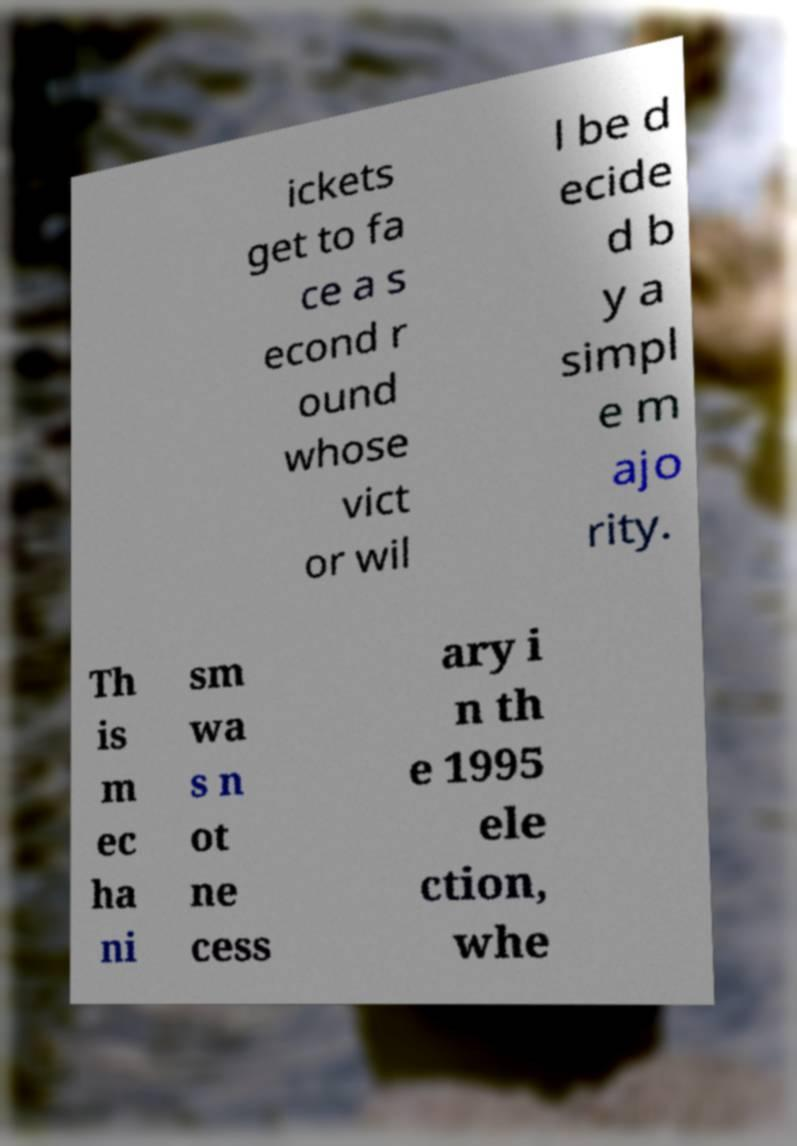Please read and relay the text visible in this image. What does it say? ickets get to fa ce a s econd r ound whose vict or wil l be d ecide d b y a simpl e m ajo rity. Th is m ec ha ni sm wa s n ot ne cess ary i n th e 1995 ele ction, whe 